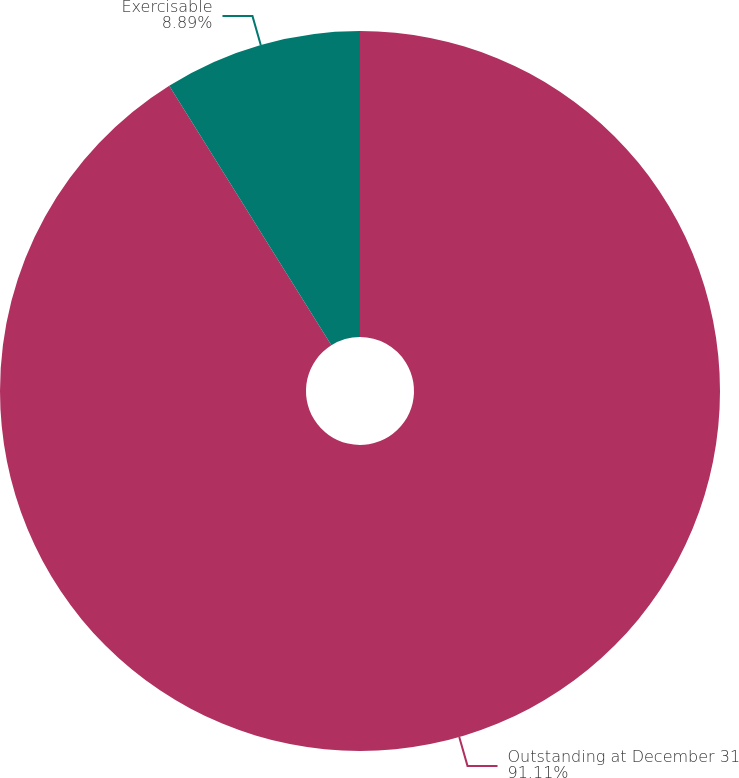Convert chart to OTSL. <chart><loc_0><loc_0><loc_500><loc_500><pie_chart><fcel>Outstanding at December 31<fcel>Exercisable<nl><fcel>91.11%<fcel>8.89%<nl></chart> 